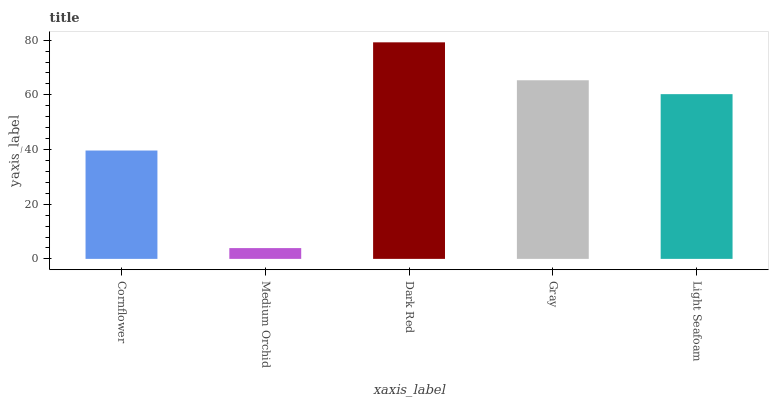Is Medium Orchid the minimum?
Answer yes or no. Yes. Is Dark Red the maximum?
Answer yes or no. Yes. Is Dark Red the minimum?
Answer yes or no. No. Is Medium Orchid the maximum?
Answer yes or no. No. Is Dark Red greater than Medium Orchid?
Answer yes or no. Yes. Is Medium Orchid less than Dark Red?
Answer yes or no. Yes. Is Medium Orchid greater than Dark Red?
Answer yes or no. No. Is Dark Red less than Medium Orchid?
Answer yes or no. No. Is Light Seafoam the high median?
Answer yes or no. Yes. Is Light Seafoam the low median?
Answer yes or no. Yes. Is Gray the high median?
Answer yes or no. No. Is Gray the low median?
Answer yes or no. No. 